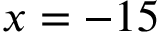<formula> <loc_0><loc_0><loc_500><loc_500>x = - 1 5</formula> 